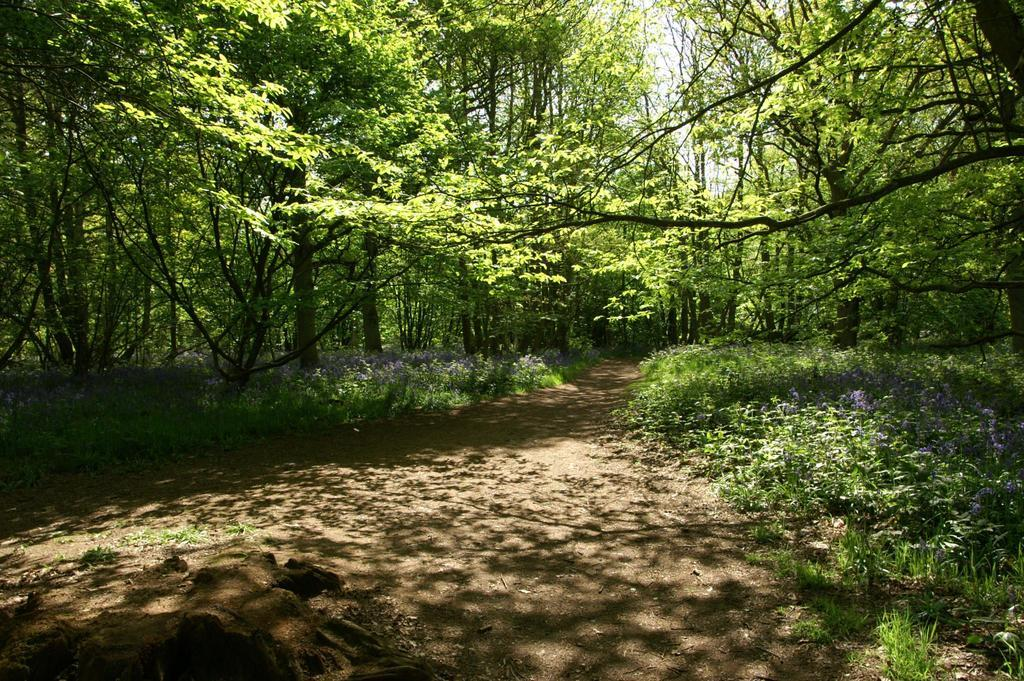What type of vegetation can be seen in the image? There are plants and trees in the image. What can be seen in the background of the image? The sky is visible in the background of the image. What type of pie is being served in the image? There is no pie present in the image; it features plants, trees, and the sky. What type of liquid can be seen flowing through the yard in the image? There is no yard or liquid present in the image; it only shows plants, trees, and the sky. 